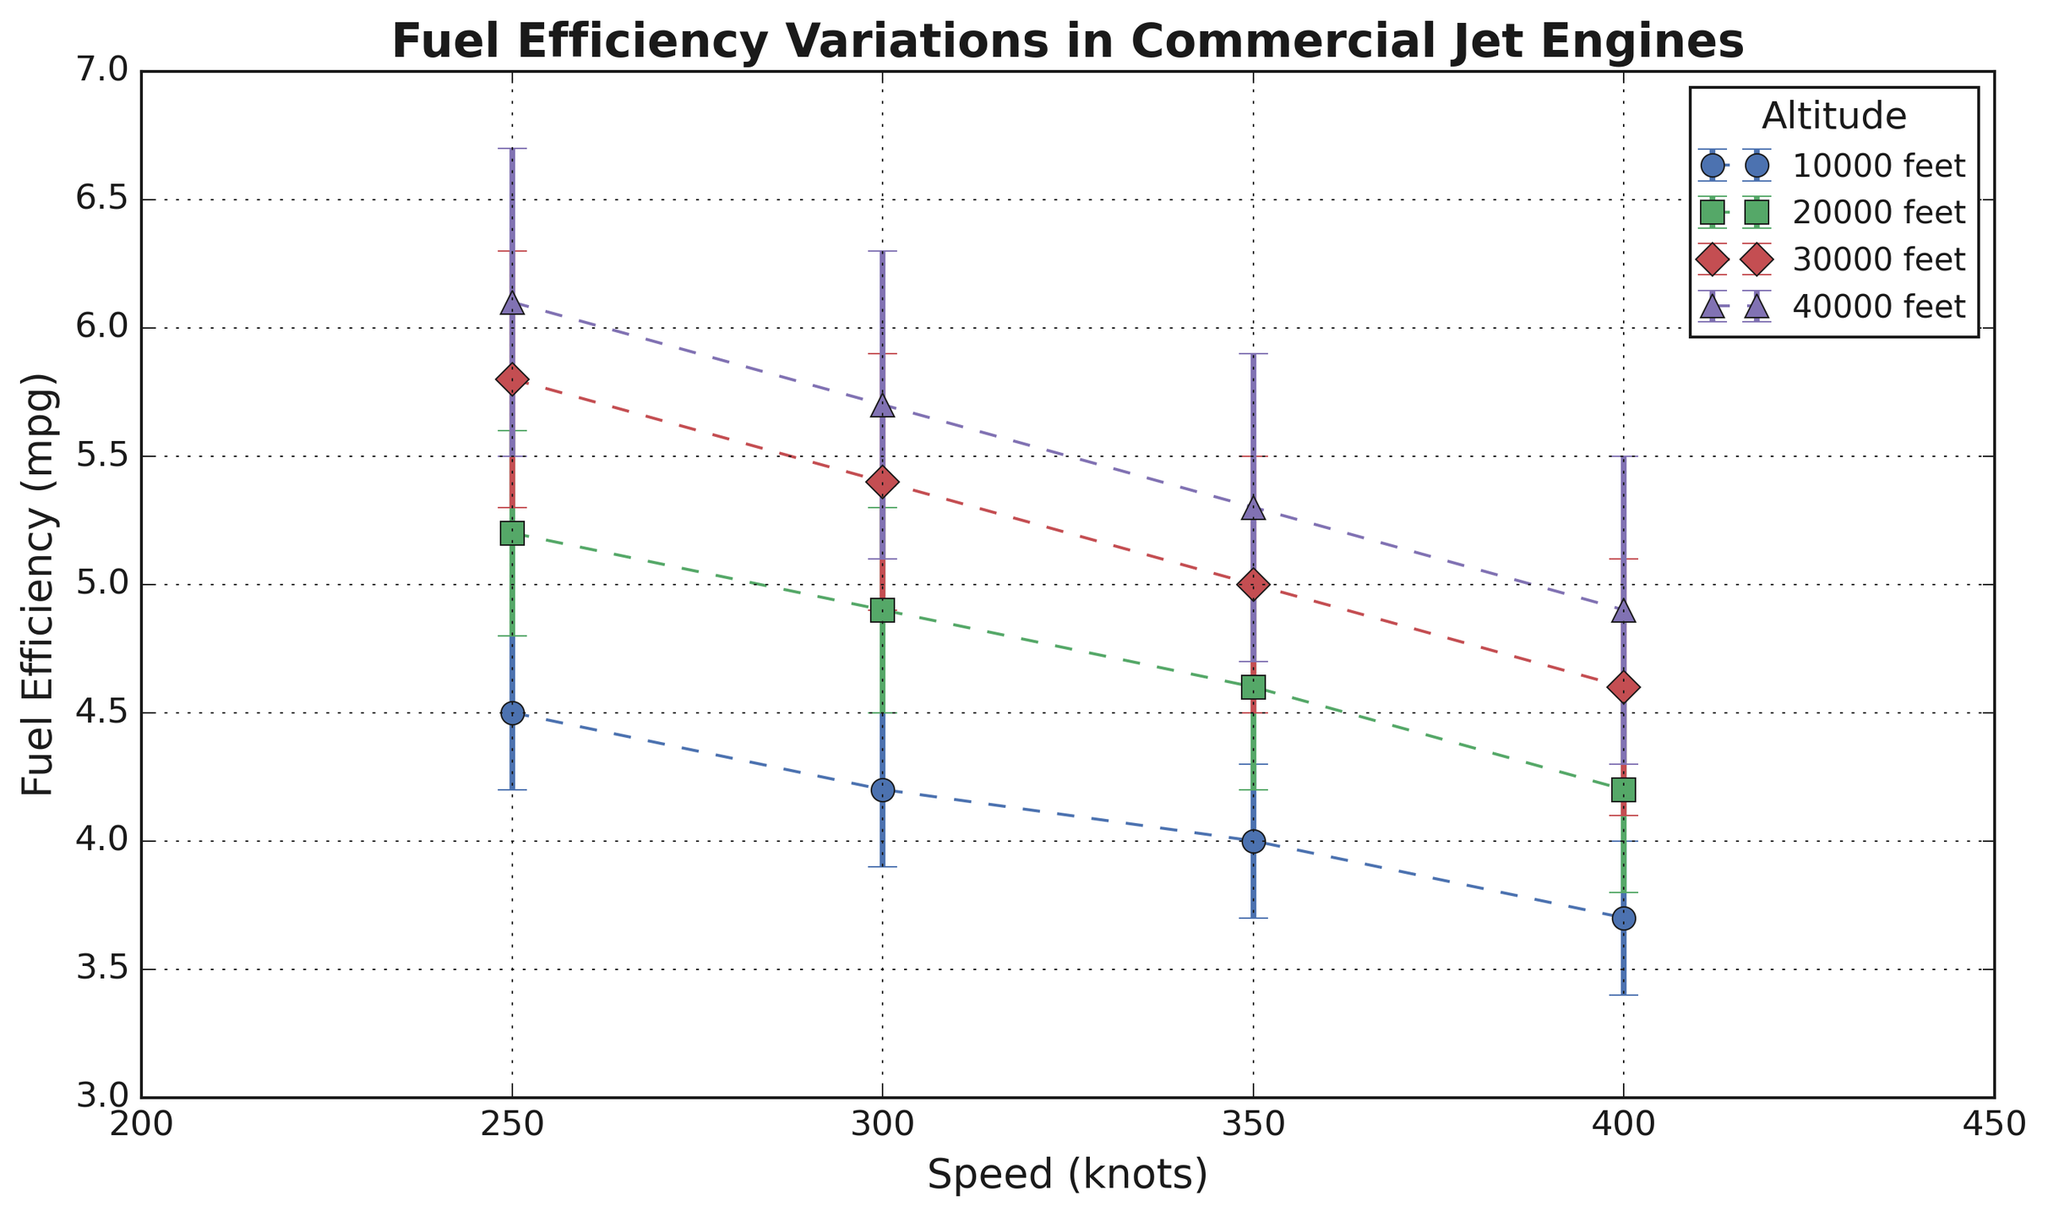What is the fuel efficiency at 30,000 feet and 300 knots? Locate the line and marker (circle) corresponding to 30,000 feet and the data point where speed reads 300 knots. The y-axis value for this point shows the fuel efficiency.
Answer: 5.4 mpg Which altitude range demonstrates the highest average fuel efficiency? Calculate the average fuel efficiency for each altitude across all speeds, then compare these averages. For 10,000 feet: (4.5 + 4.2 + 4.0 + 3.7) / 4 = 4.1. For 20,000 feet: (5.2 + 4.9 + 4.6 + 4.2) / 4 = 4.725. For 30,000 feet: (5.8 + 5.4 + 5.0 + 4.6) / 4 = 5.2. For 40,000 feet: (6.1 + 5.7 + 5.3 + 4.9) / 4 = 5.5. Comparing these, 40,000 feet has the highest average fuel efficiency.
Answer: 40,000 feet At which speed does fuel efficiency decrease most rapidly across all altitudes? Identify where the drop in fuel efficiency is largest between successive speed values for all altitudes. At each speed transition (250 to 300, 300 to 350, and 350 to 400 knots), calculate the drop. For example, for 10,000 feet from 250 to 300 knots, the decrease is 4.5 - 4.2 = 0.3. Compare the drops across all these transitions, the largest drop is from 300 to 350 knots at an average fall [(0.3 + 0.3 + 0.4 + 0.4) / 4 = 0.35].
Answer: 300 to 350 knots Does the error margin increase with altitude? Examine and compare the error margins on the error bars for each altitude. The data shows margins of 0.3 for 10,000, 0.4 for 20,000, 0.5 for 30,000, and 0.6 for 40,000 feet, indicating a trend of increasing error margins with altitude.
Answer: Yes How does fuel efficiency at 20,000 feet and 400 knots compare to 40,000 feet and 250 knots? Determine the fuel efficiency values for both points by cross-referencing the altitude and speed data. At 20,000 feet and 400 knots, the fuel efficiency is 4.2 mpg. At 40,000 feet and 250 knots, it is 6.1 mpg. The efficiency at 40,000 feet and 250 knots is higher.
Answer: Higher at 40,000 feet and 250 knots What is the difference in fuel efficiency between 10,000 feet and 40,000 feet at 350 knots? Find the fuel efficiency at 350 knots for both altitudes by referring to their points. At 10,000 feet it's 4.0 mpg, and at 40,000 feet it's 5.3 mpg. Calculate the difference: 5.3 - 4.0 = 1.3.
Answer: 1.3 mpg Which altitude shows the least variation in fuel efficiency across the speeds? Calculate the variation (range) in fuel efficiency for each altitude by subtracting the minimum from the maximum value for each altitude. Variations are: 10,000 feet: 4.5 - 3.7 = 0.8; 20,000 feet: 5.2 - 4.2 = 1.0; 30,000 feet: 5.8 - 4.6 = 1.2; 40,000 feet: 6.1 - 4.9 = 1.2. 10,000 feet shows the least variation.
Answer: 10,000 feet Does higher altitude consistently result in greater fuel efficiency across all speeds? Checking each speed category (250, 300, 350, and 400 knots), compare fuel efficiencies at different altitudes. For 250 knots: 4.5, 5.2, 5.8, 6.1 (yes); for 300 knots: 4.2, 4.9, 5.4, 5.7 (yes); for 350 knots: 4.0, 4.6, 5.0, 5.3 (yes); for 400 knots: 3.7, 4.2, 4.6, 4.9 (yes). Consistently higher efficiency is indicated.
Answer: Yes 